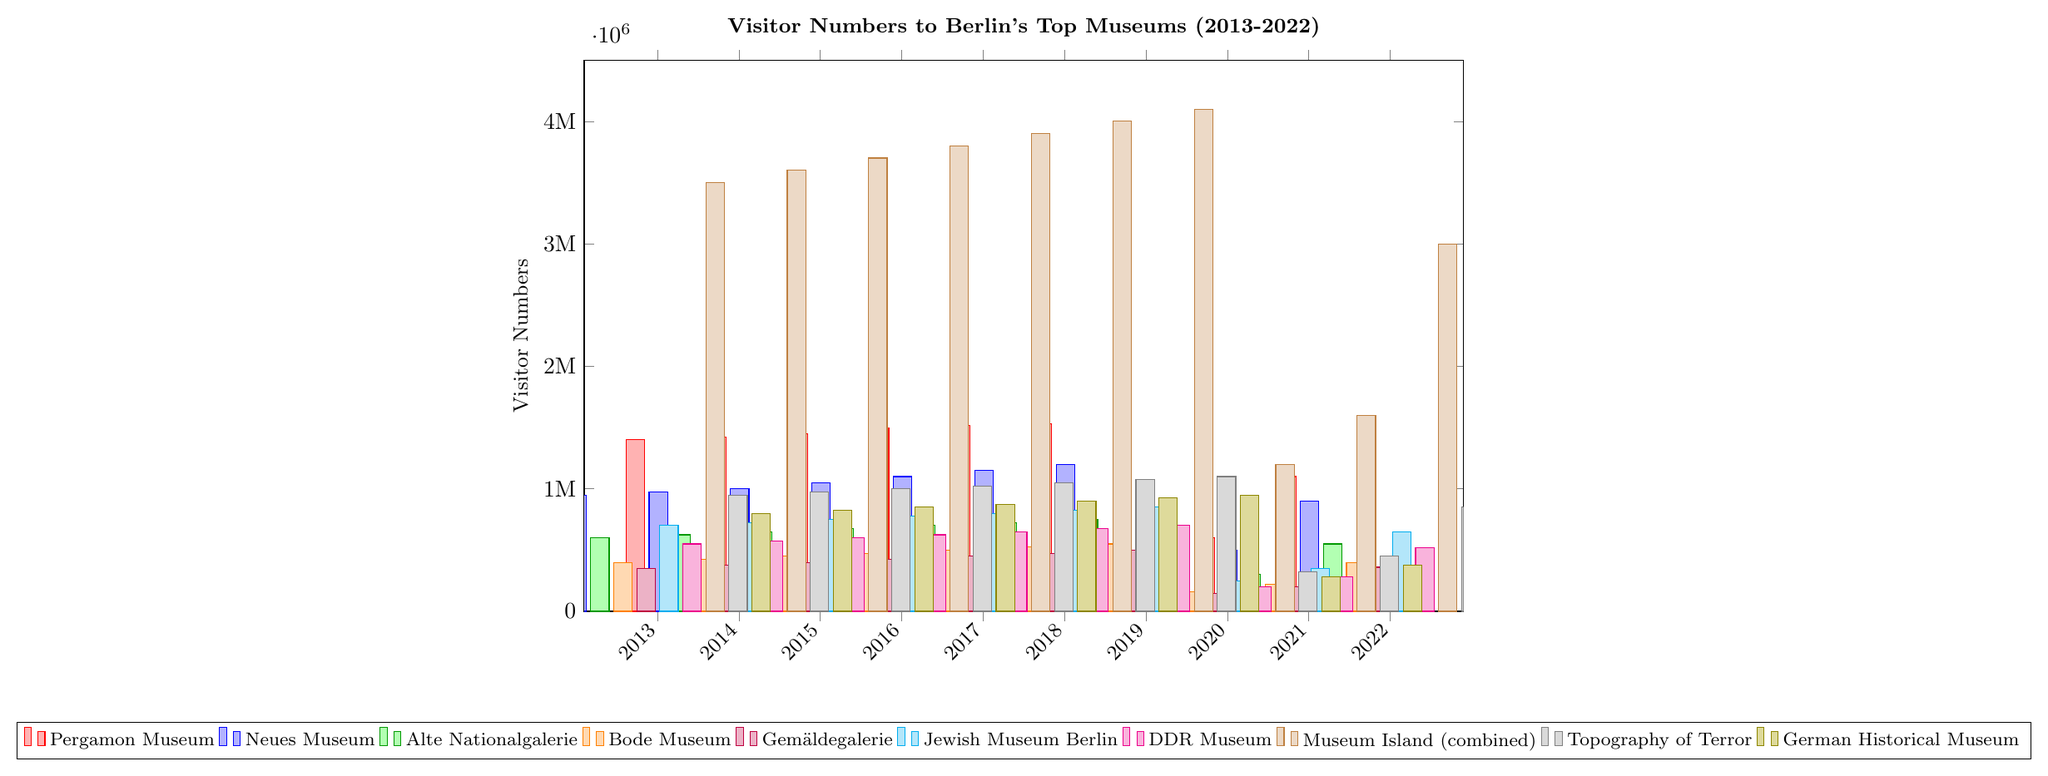Which museum had the highest number of visitors in 2019? Look at the bar heights for 2019 and identify the museum with the tallest bar.
Answer: Museum Island (combined) How did the visitor numbers for the Pergamon Museum change from 2019 to 2020? Compare the height of the bars representing the Pergamon Museum in 2019 and 2020.
Answer: Decreased Which year saw the lowest visitor numbers across all museums? Identify the year with the smallest bars across all museums.
Answer: 2020 In 2022, which museum had more visitors: the Neues Museum or the Jewish Museum Berlin? Compare the heights of the bars for the Neues Museum and the Jewish Museum Berlin in 2022.
Answer: Neues Museum What is the difference in visitor numbers between the German Historical Museum and the Bode Museum in 2016? Subtract the height of the Bode Museum bar from the height of the German Historical Museum bar for 2016.
Answer: 400,000 Which museum showed the most significant decline in visitors from 2019 to 2020? Calculate the difference in bar heights for each museum between 2019 and 2020 and identify the largest decline.
Answer: Museum Island (combined) What is the average number of visitors to the Alte Nationalgalerie over the decade? Add up the visitor numbers for the Alte Nationalgalerie from 2013 to 2022, then divide by 10.
Answer: 554,000 Compare the visitor trends of Museum Island (combined) and the Gemäldegalerie from 2013 to 2022. Which one had more consistent visitor numbers? Look at the changes in bar heights over the years for both museums and note which one fluctuates less.
Answer: Gemäldegalerie Between the Bode Museum and the DDR Museum, which had a higher visitor increase from 2021 to 2022? Calculate the differences in visitor numbers for both museums between 2021 and 2022 and compare.
Answer: Bode Museum What was the percentage drop in visitors to the Pergamon Museum from 2019 to 2020? Calculate the difference in visitors between 2019 and 2020, then divide by the 2019 number and multiply by 100 to get the percentage.
Answer: 70.6% 